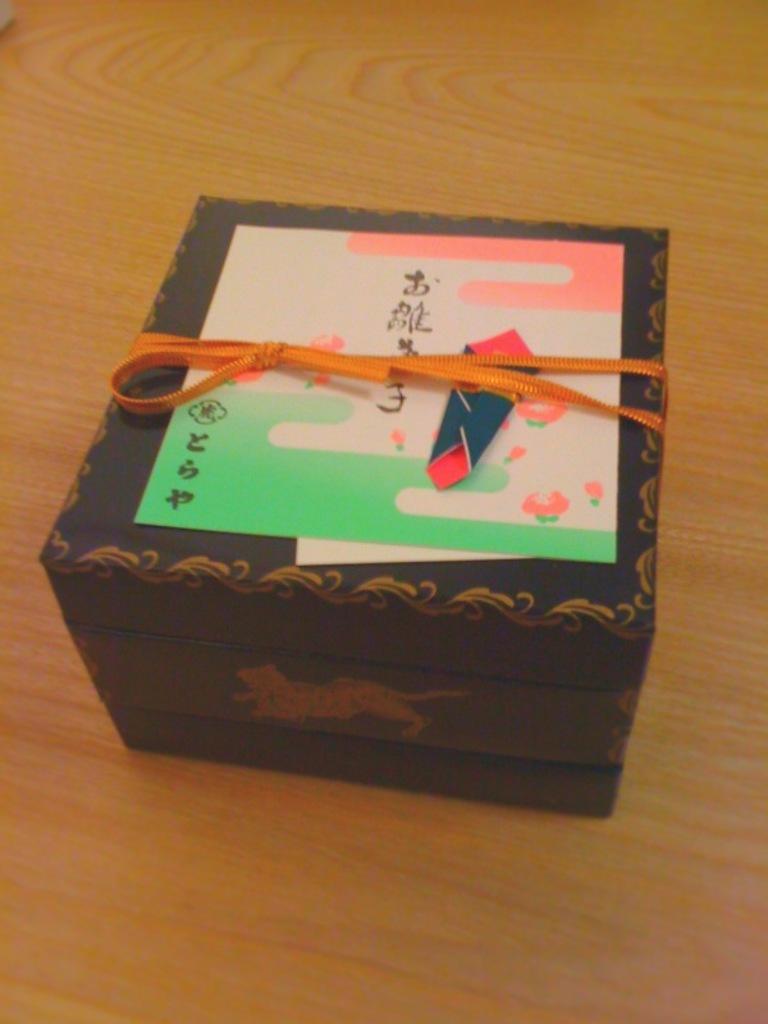Text is in foreign language?
Your response must be concise. Yes. 